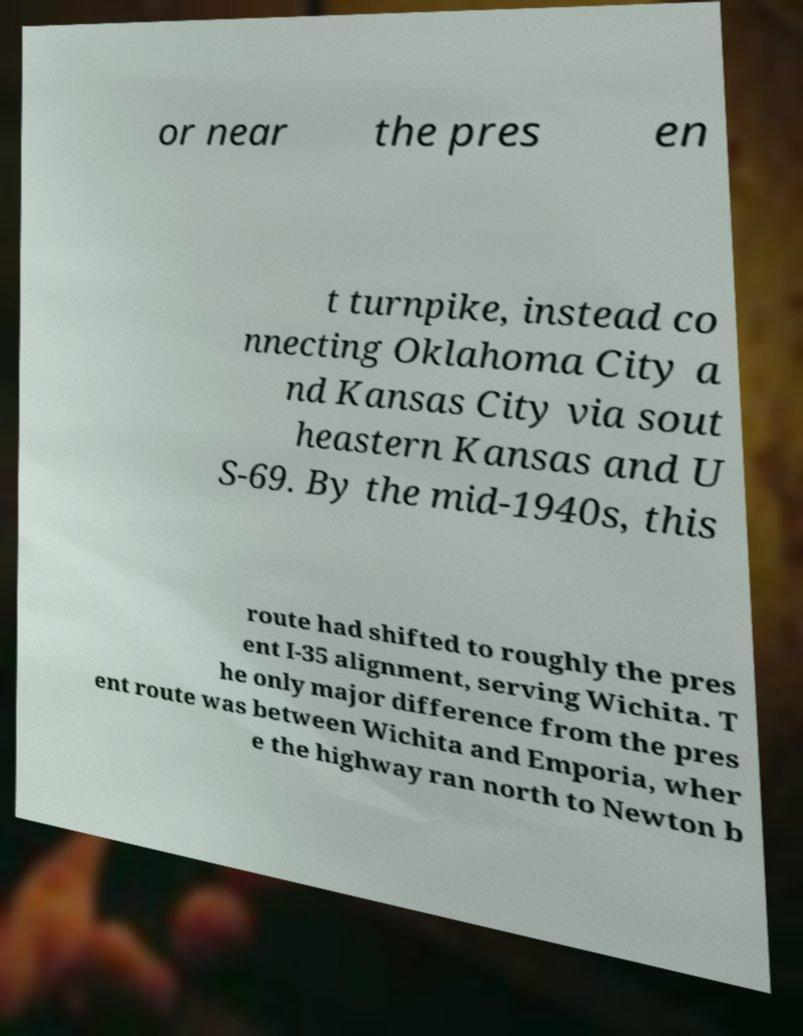Could you extract and type out the text from this image? or near the pres en t turnpike, instead co nnecting Oklahoma City a nd Kansas City via sout heastern Kansas and U S-69. By the mid-1940s, this route had shifted to roughly the pres ent I-35 alignment, serving Wichita. T he only major difference from the pres ent route was between Wichita and Emporia, wher e the highway ran north to Newton b 